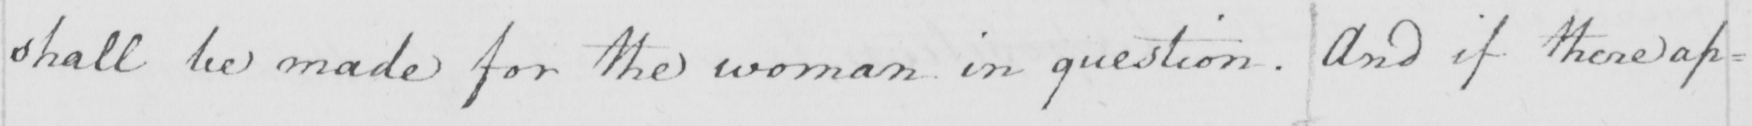Can you read and transcribe this handwriting? shall be made for the woman in question . And if there ap= 